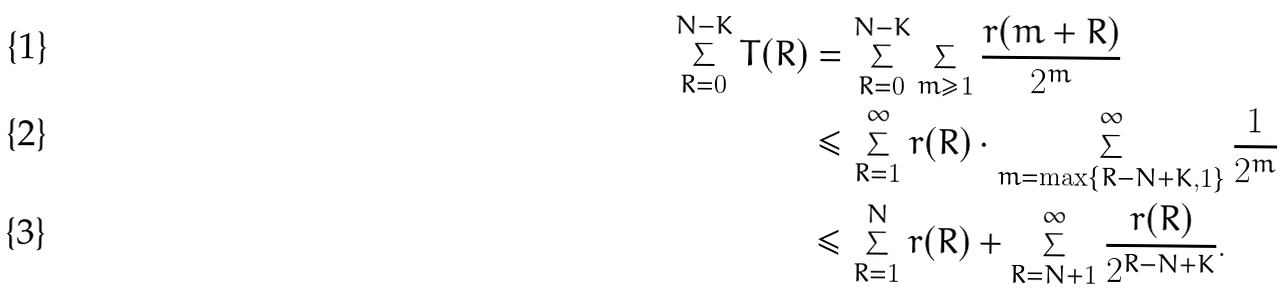Convert formula to latex. <formula><loc_0><loc_0><loc_500><loc_500>\sum _ { R = 0 } ^ { N - K } T ( R ) & = \sum _ { R = 0 } ^ { N - K } \sum _ { m \geq 1 } \frac { r ( m + R ) } { 2 ^ { m } } \\ & \leq \sum _ { R = 1 } ^ { \infty } r ( R ) \cdot \sum _ { m = \max \{ R - N + K , 1 \} } ^ { \infty } \frac { 1 } { 2 ^ { m } } \\ & \leq \sum _ { R = 1 } ^ { N } r ( R ) + \sum _ { R = N + 1 } ^ { \infty } \frac { r ( R ) } { 2 ^ { R - N + K } } .</formula> 